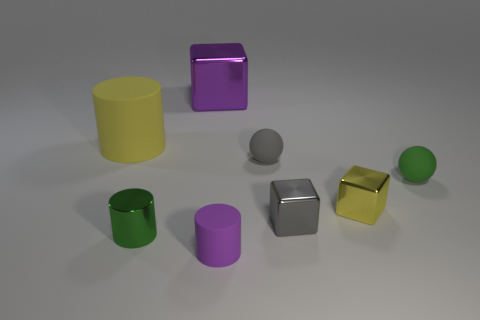Subtract all purple blocks. How many blocks are left? 2 Add 2 tiny purple matte cylinders. How many objects exist? 10 Subtract all gray cubes. How many cubes are left? 2 Subtract 2 blocks. How many blocks are left? 1 Add 7 tiny yellow metallic blocks. How many tiny yellow metallic blocks are left? 8 Add 3 purple things. How many purple things exist? 5 Subtract 1 green spheres. How many objects are left? 7 Subtract all cubes. How many objects are left? 5 Subtract all gray blocks. Subtract all yellow cylinders. How many blocks are left? 2 Subtract all small yellow matte cylinders. Subtract all big objects. How many objects are left? 6 